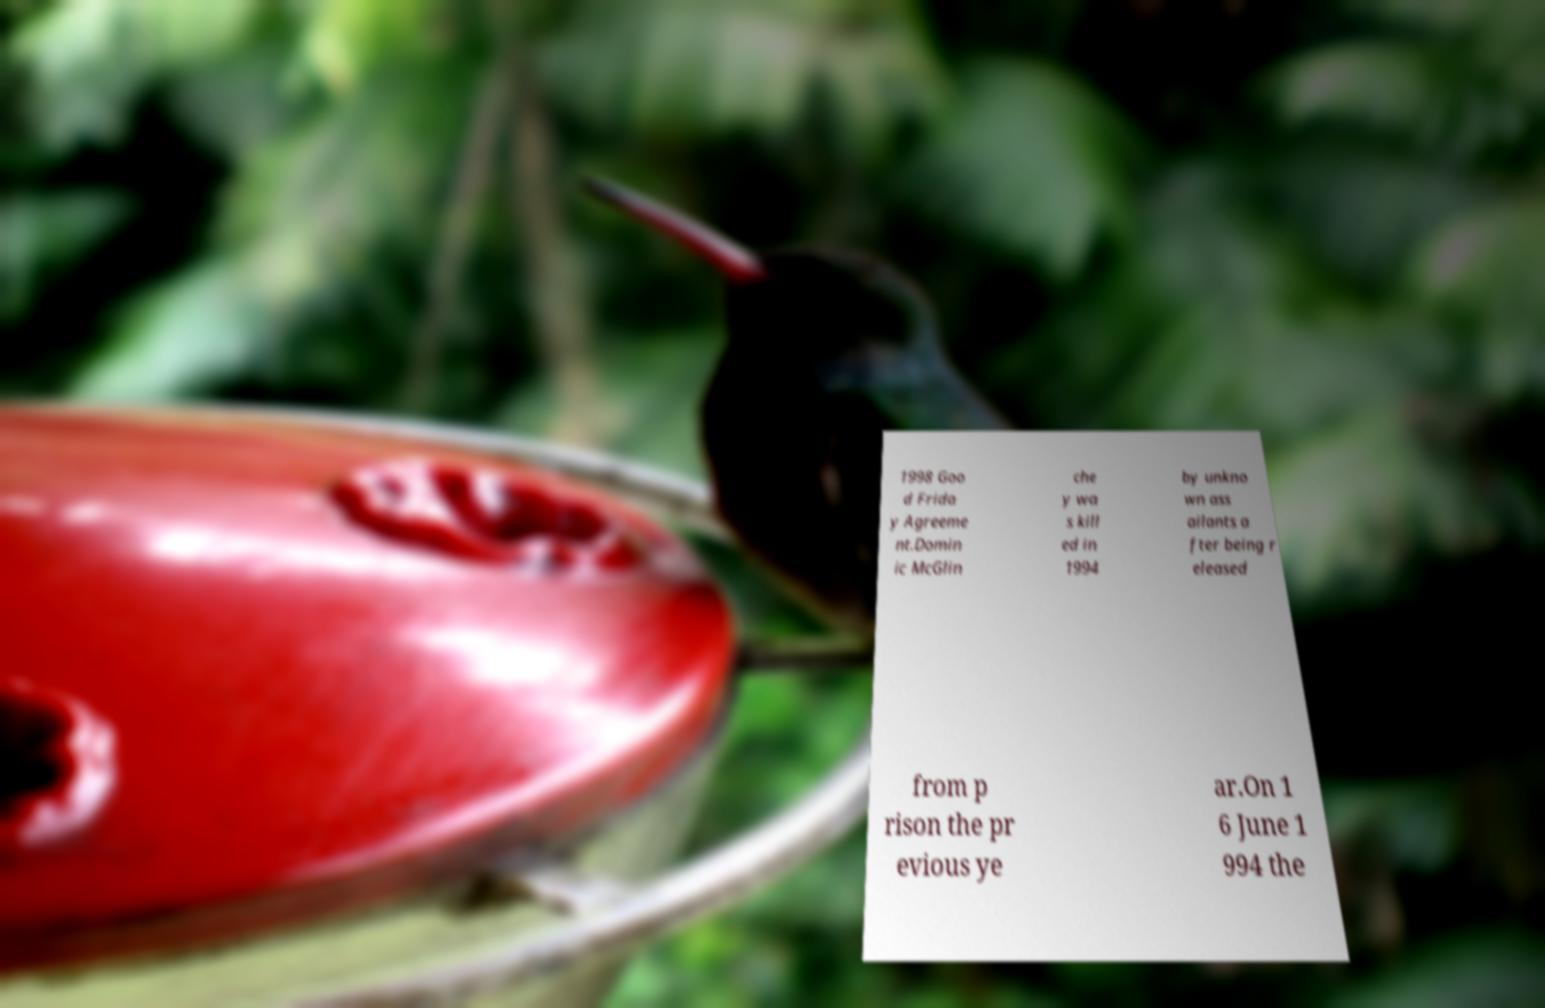For documentation purposes, I need the text within this image transcribed. Could you provide that? 1998 Goo d Frida y Agreeme nt.Domin ic McGlin che y wa s kill ed in 1994 by unkno wn ass ailants a fter being r eleased from p rison the pr evious ye ar.On 1 6 June 1 994 the 